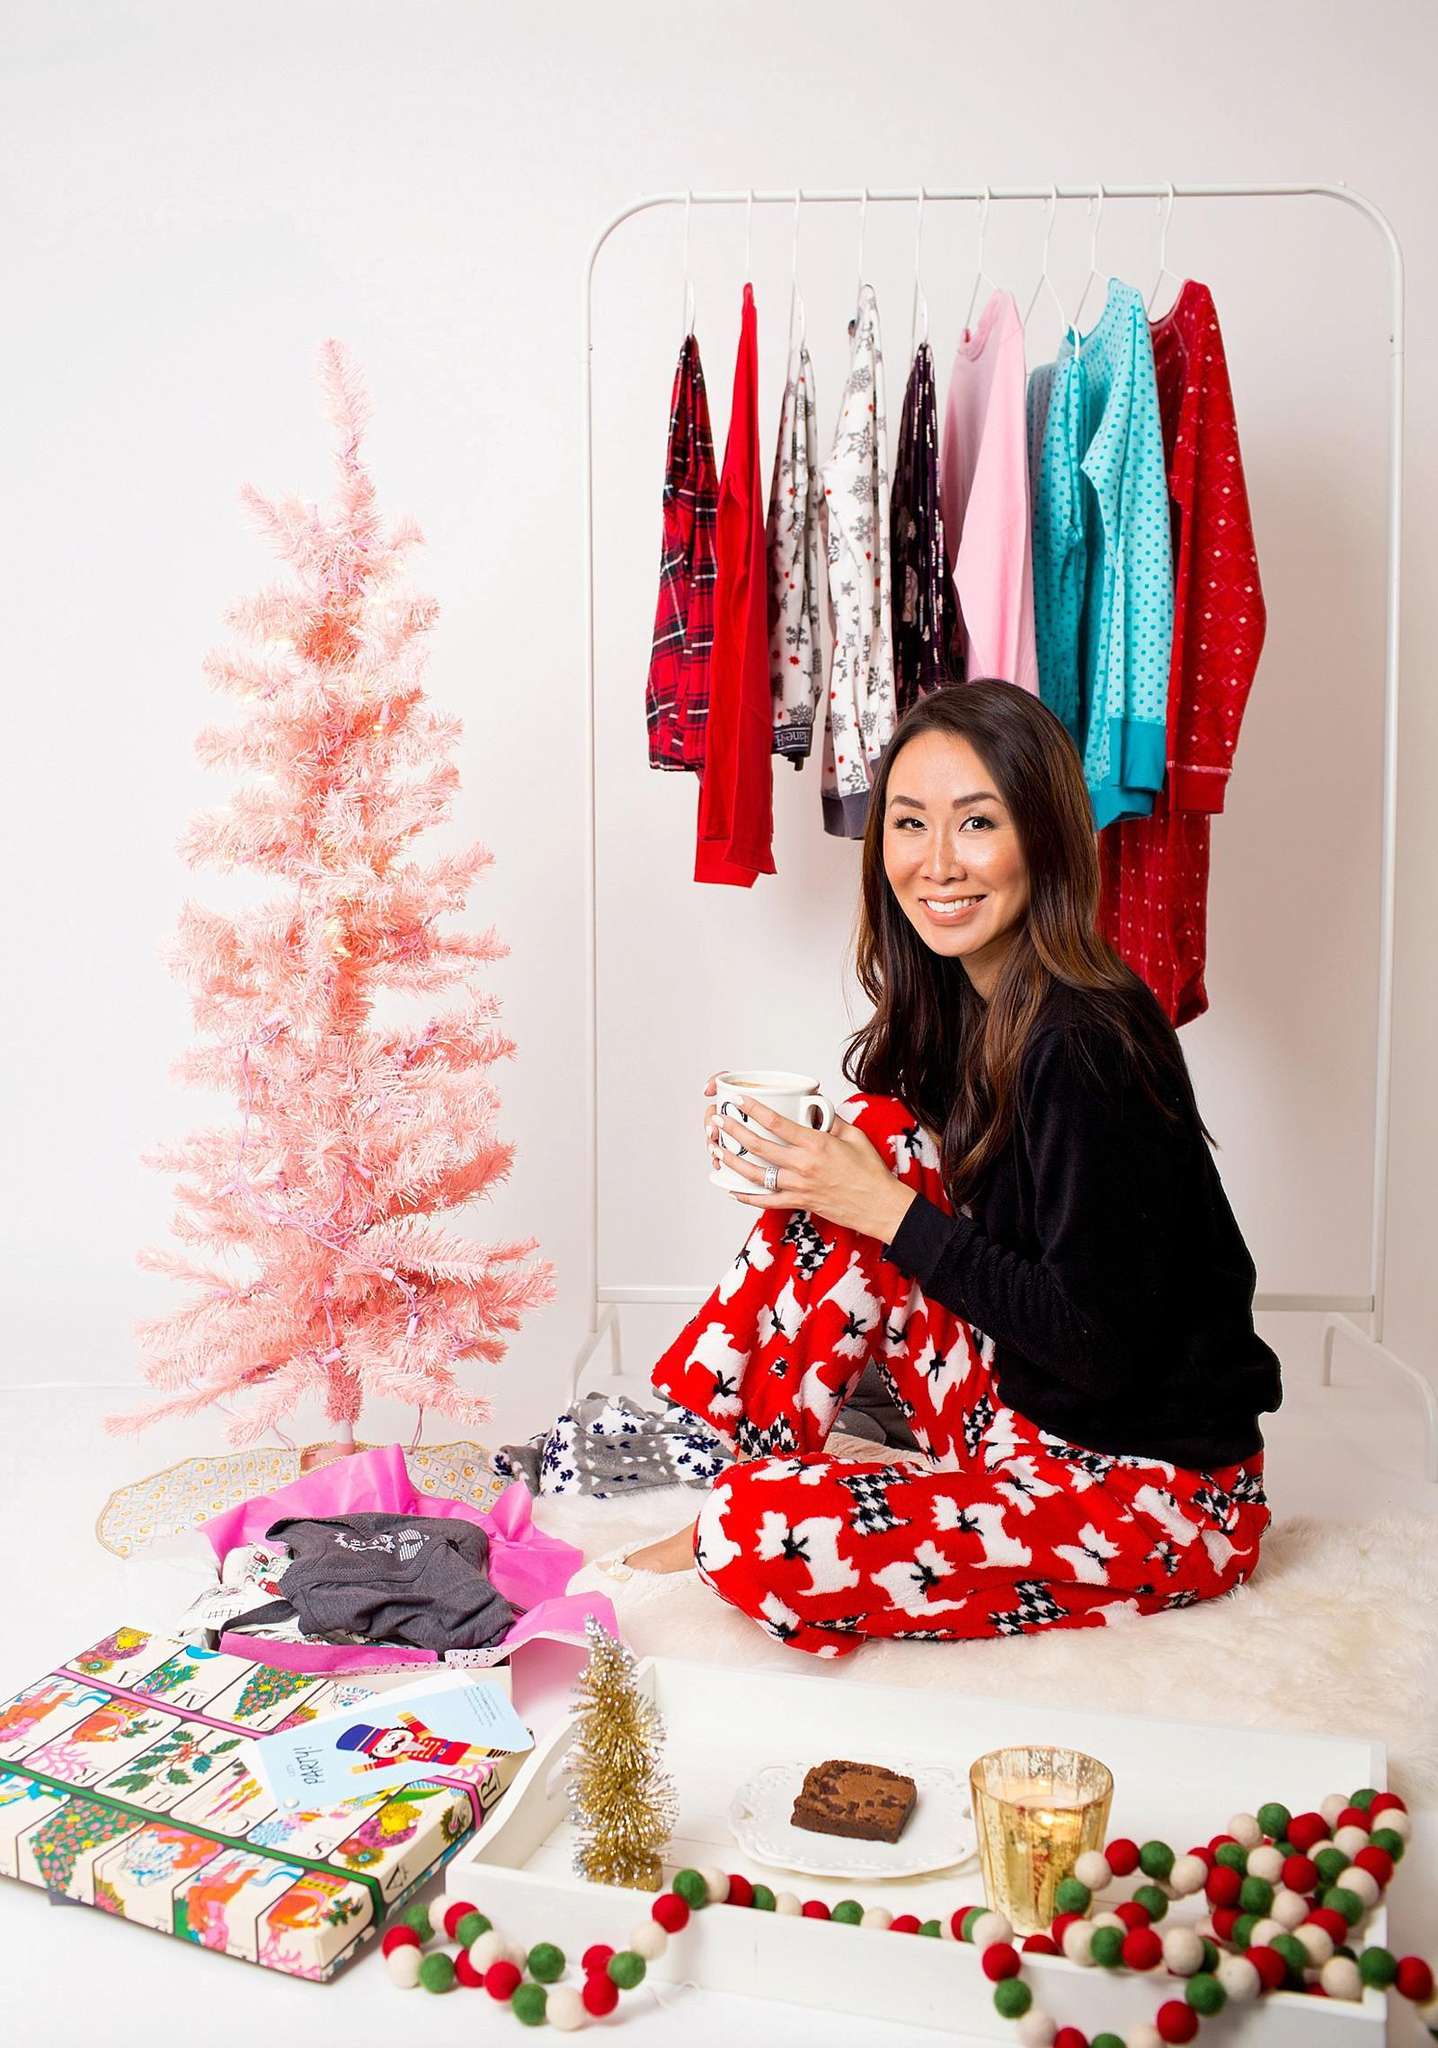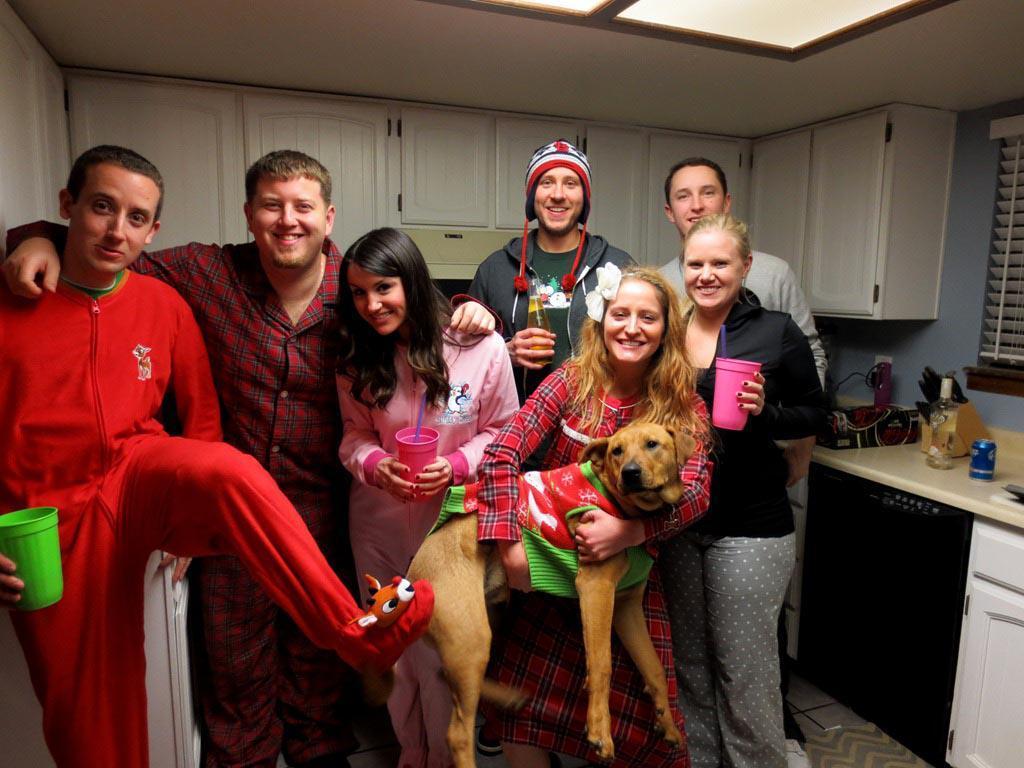The first image is the image on the left, the second image is the image on the right. Analyze the images presented: Is the assertion "An image shows a woman in printed pj pants sitting in front of a small pink Christmas tree." valid? Answer yes or no. Yes. 